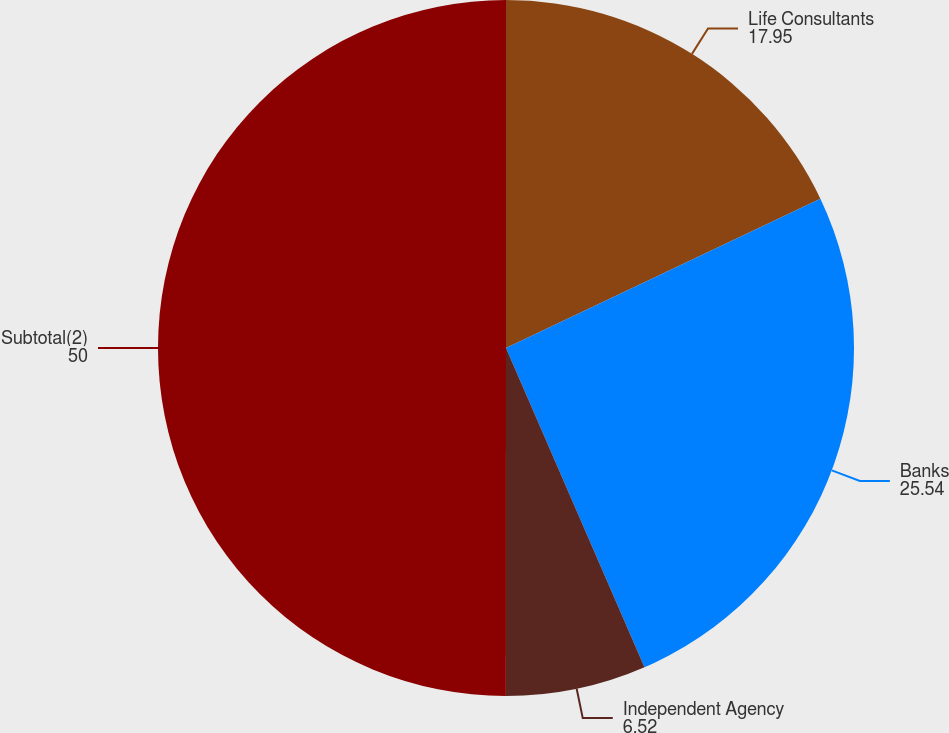<chart> <loc_0><loc_0><loc_500><loc_500><pie_chart><fcel>Life Consultants<fcel>Banks<fcel>Independent Agency<fcel>Subtotal(2)<nl><fcel>17.95%<fcel>25.54%<fcel>6.52%<fcel>50.0%<nl></chart> 